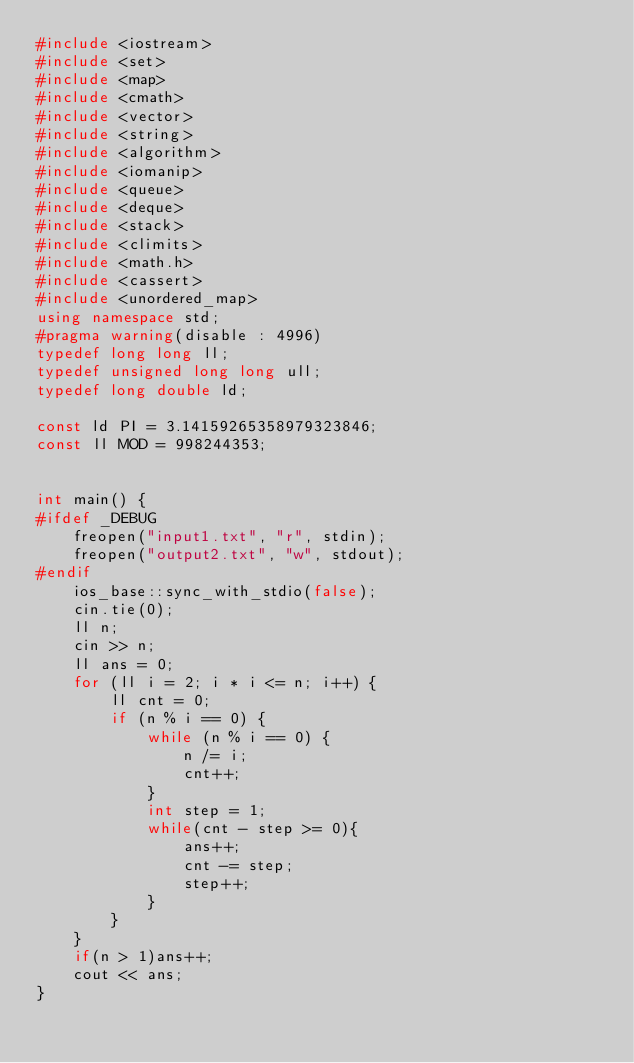Convert code to text. <code><loc_0><loc_0><loc_500><loc_500><_C++_>#include <iostream>
#include <set>
#include <map>
#include <cmath>
#include <vector>
#include <string>
#include <algorithm>
#include <iomanip>
#include <queue>
#include <deque>
#include <stack>
#include <climits>
#include <math.h>
#include <cassert>
#include <unordered_map>
using namespace std;
#pragma warning(disable : 4996)
typedef long long ll;
typedef unsigned long long ull;
typedef long double ld;
 
const ld PI = 3.14159265358979323846;
const ll MOD = 998244353;
 
 
int main() {
#ifdef _DEBUG
	freopen("input1.txt", "r", stdin);
	freopen("output2.txt", "w", stdout);
#endif
	ios_base::sync_with_stdio(false);
	cin.tie(0);
	ll n;
	cin >> n;
	ll ans = 0;
	for (ll i = 2; i * i <= n; i++) {
		ll cnt = 0;
		if (n % i == 0) {
			while (n % i == 0) {
				n /= i;
				cnt++;
			}
		    int step = 1;
		    while(cnt - step >= 0){
		        ans++;
		        cnt -= step;
		        step++;
		    }
		}
	}
    if(n > 1)ans++;
    cout << ans;
}</code> 